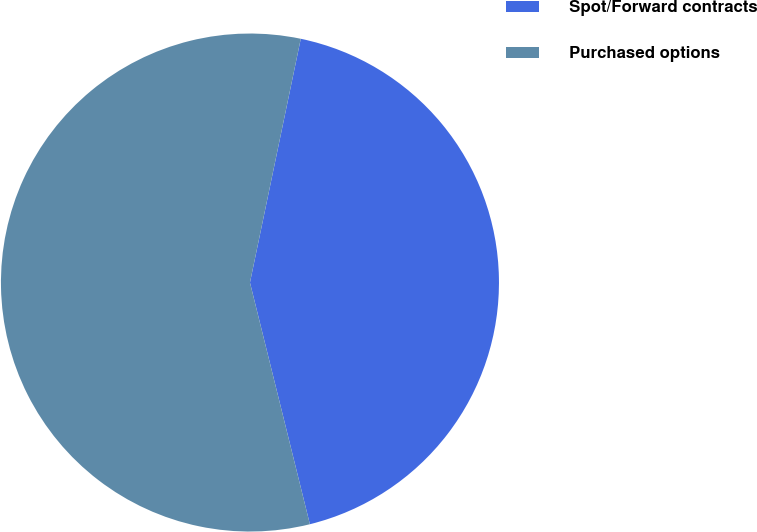<chart> <loc_0><loc_0><loc_500><loc_500><pie_chart><fcel>Spot/Forward contracts<fcel>Purchased options<nl><fcel>42.86%<fcel>57.14%<nl></chart> 